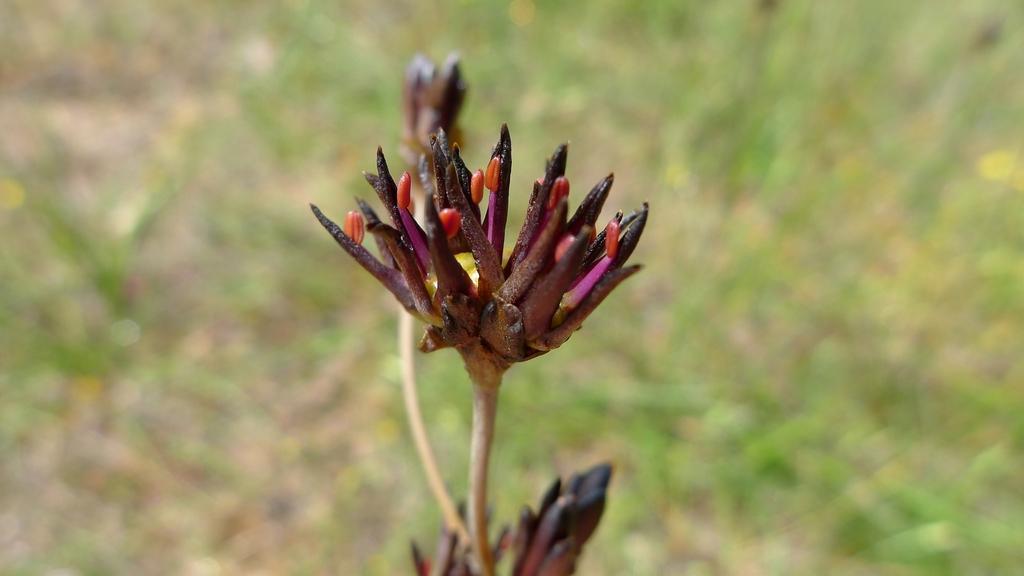Please provide a concise description of this image. In this image I can see the flowers to the stems. In the background, I can see few plants on the ground. 